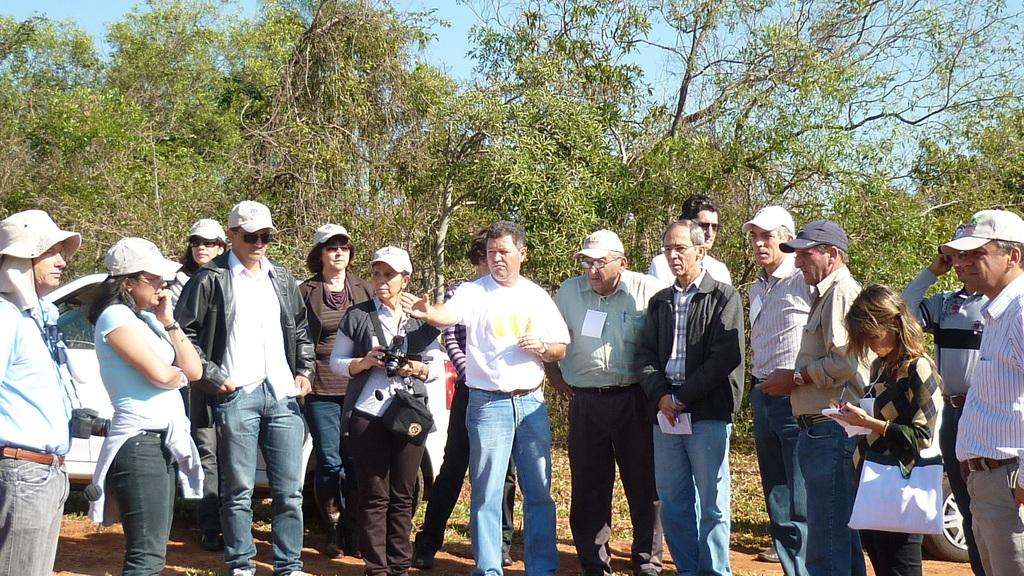What are the people in the middle of the image doing? The people in the middle of the image are standing and holding papers and cameras. What can be seen in the background of the image? There are vehicles and trees visible in the background. What is visible at the top of the image? The sky is visible at the top of the image. What type of pear is being used as a prop in the image? There is no pear present in the image. How many people are in the crowd in the image? There is no crowd present in the image; it features a few people standing in the middle. 